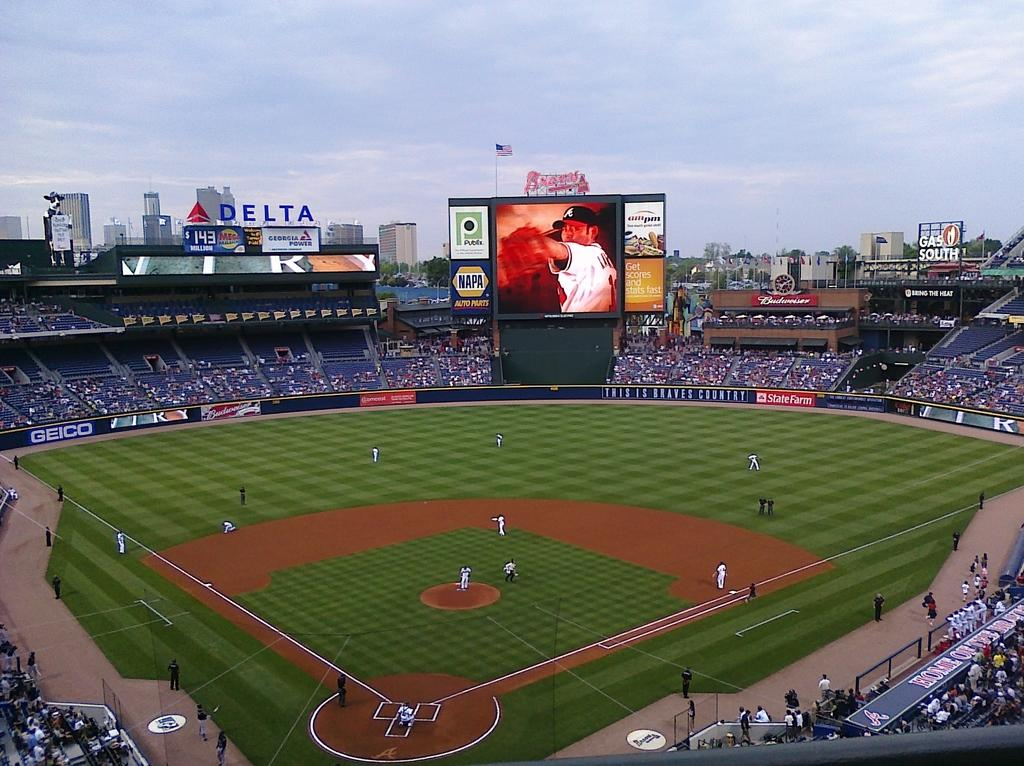<image>
Offer a succinct explanation of the picture presented. A Napa Auto Parts sign is part of the big screen in this baseball stadium. 